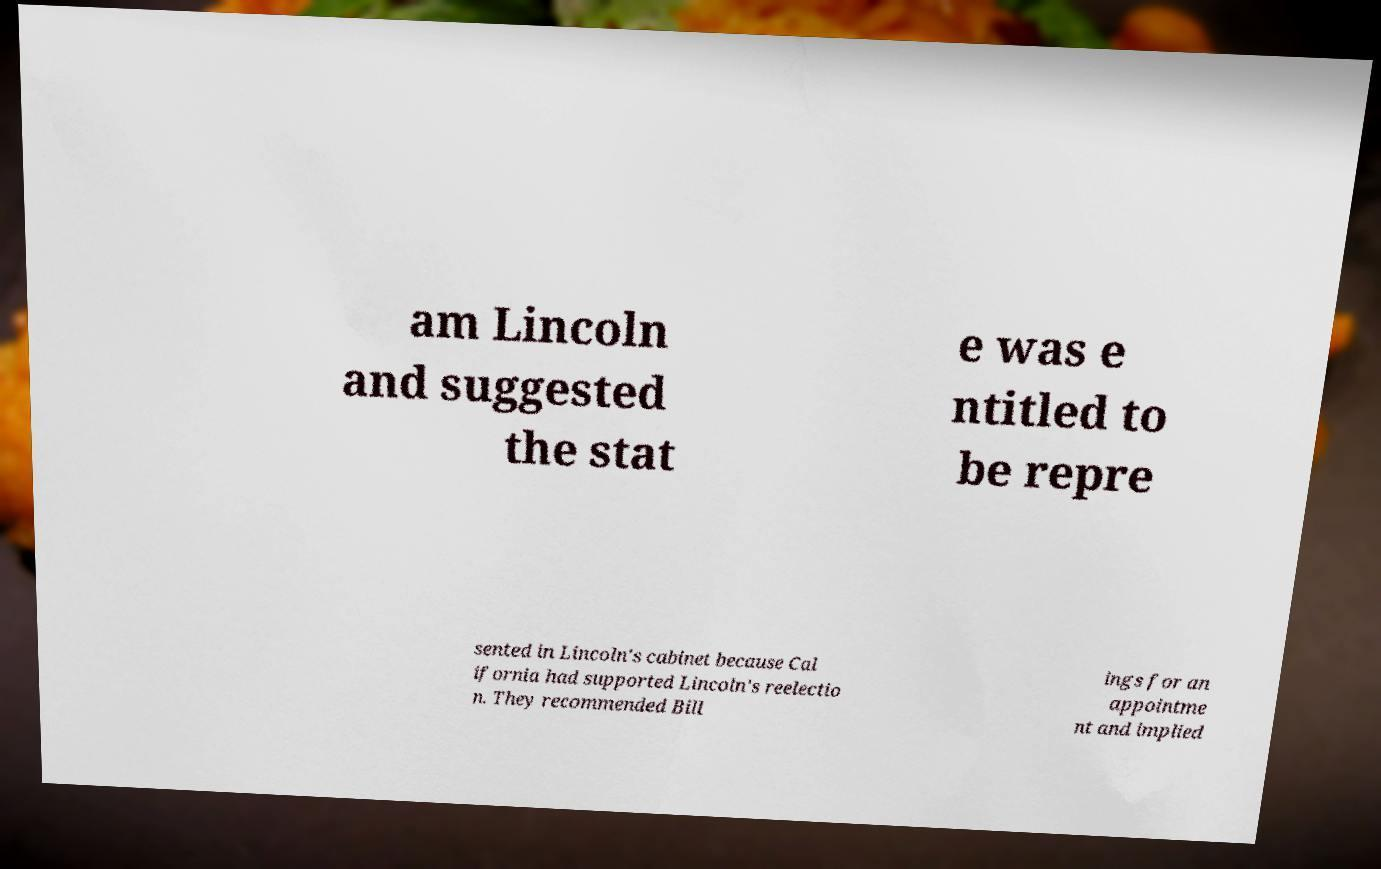There's text embedded in this image that I need extracted. Can you transcribe it verbatim? am Lincoln and suggested the stat e was e ntitled to be repre sented in Lincoln's cabinet because Cal ifornia had supported Lincoln's reelectio n. They recommended Bill ings for an appointme nt and implied 